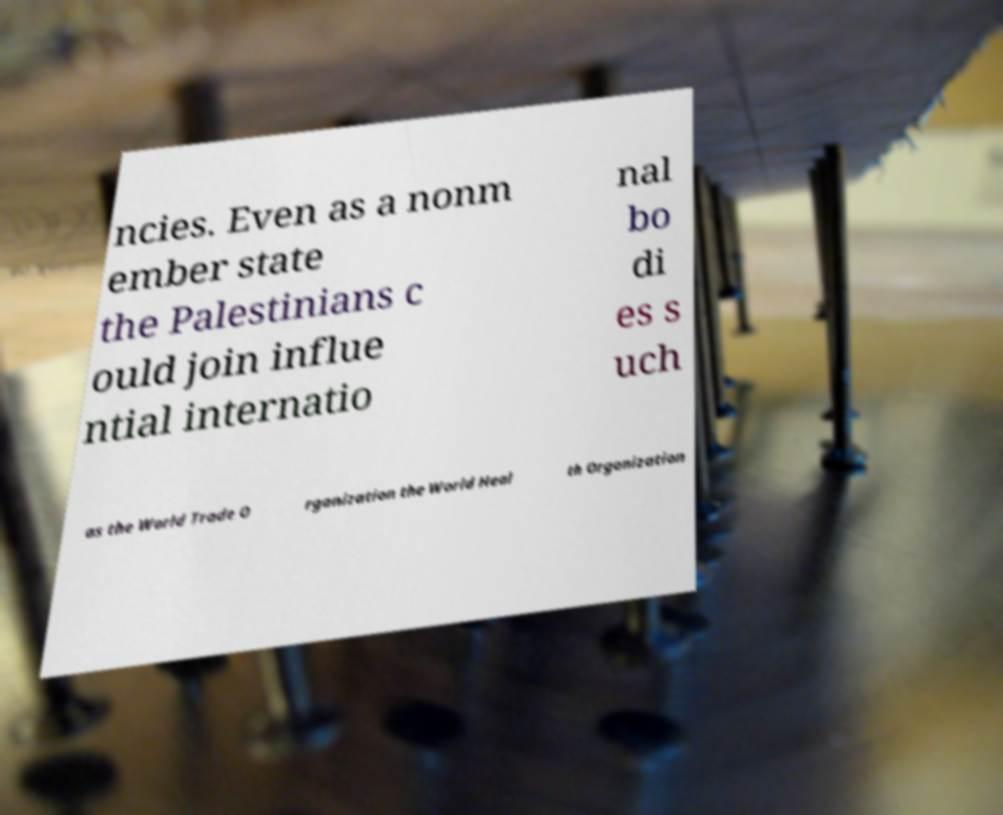Could you assist in decoding the text presented in this image and type it out clearly? ncies. Even as a nonm ember state the Palestinians c ould join influe ntial internatio nal bo di es s uch as the World Trade O rganization the World Heal th Organization 